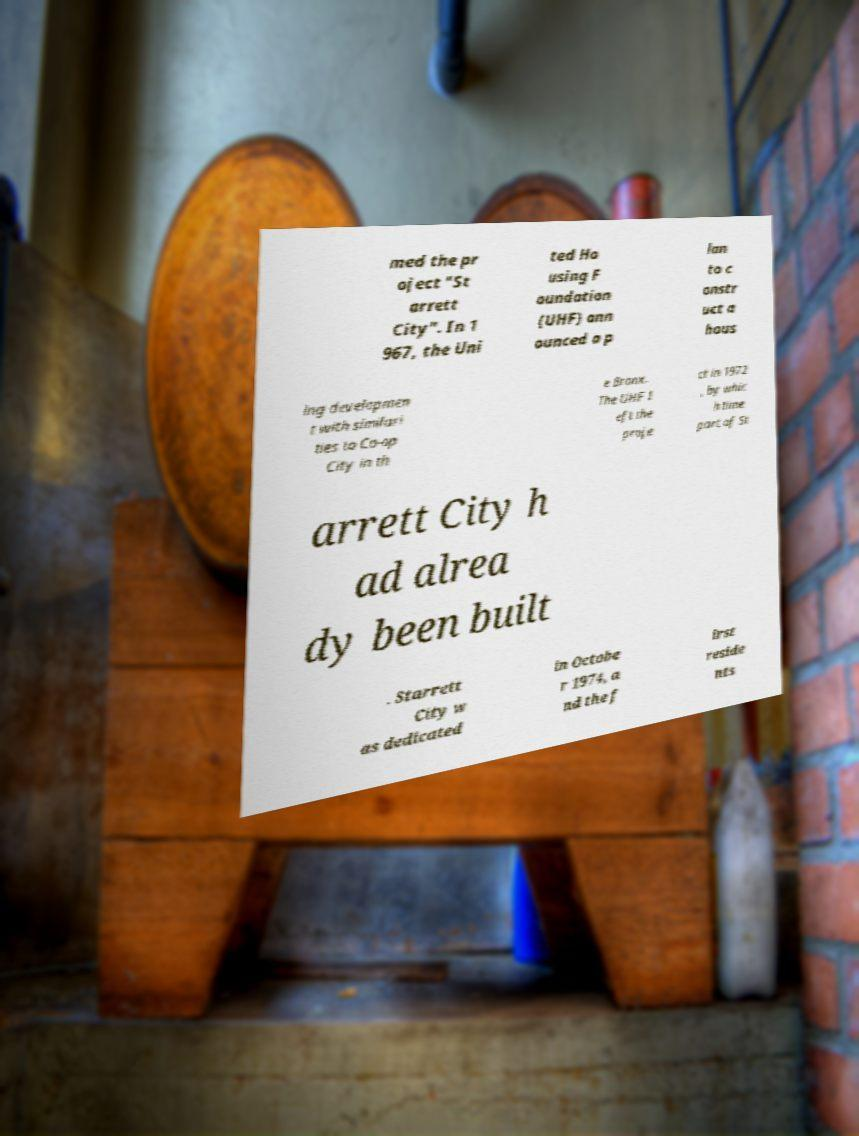Could you assist in decoding the text presented in this image and type it out clearly? med the pr oject "St arrett City". In 1 967, the Uni ted Ho using F oundation (UHF) ann ounced a p lan to c onstr uct a hous ing developmen t with similari ties to Co-op City in th e Bronx. The UHF l eft the proje ct in 1972 , by whic h time part of St arrett City h ad alrea dy been built . Starrett City w as dedicated in Octobe r 1974, a nd the f irst reside nts 